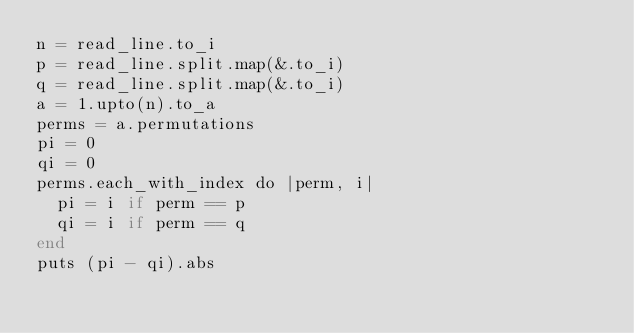<code> <loc_0><loc_0><loc_500><loc_500><_Crystal_>n = read_line.to_i
p = read_line.split.map(&.to_i)
q = read_line.split.map(&.to_i)
a = 1.upto(n).to_a
perms = a.permutations
pi = 0
qi = 0
perms.each_with_index do |perm, i|
  pi = i if perm == p
  qi = i if perm == q
end
puts (pi - qi).abs
</code> 